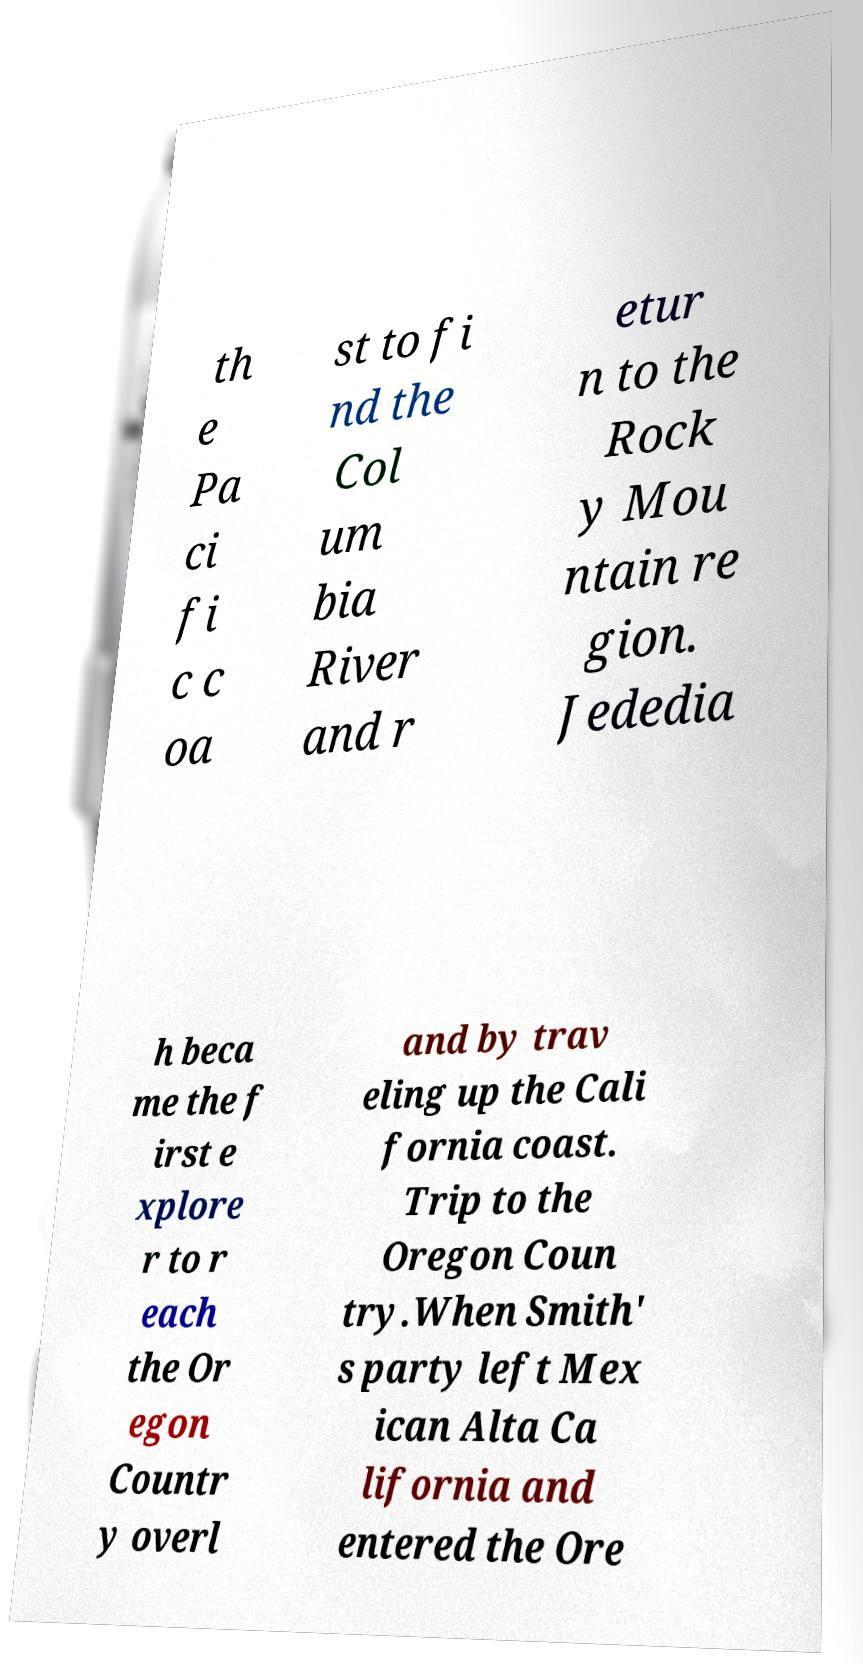I need the written content from this picture converted into text. Can you do that? th e Pa ci fi c c oa st to fi nd the Col um bia River and r etur n to the Rock y Mou ntain re gion. Jededia h beca me the f irst e xplore r to r each the Or egon Countr y overl and by trav eling up the Cali fornia coast. Trip to the Oregon Coun try.When Smith' s party left Mex ican Alta Ca lifornia and entered the Ore 